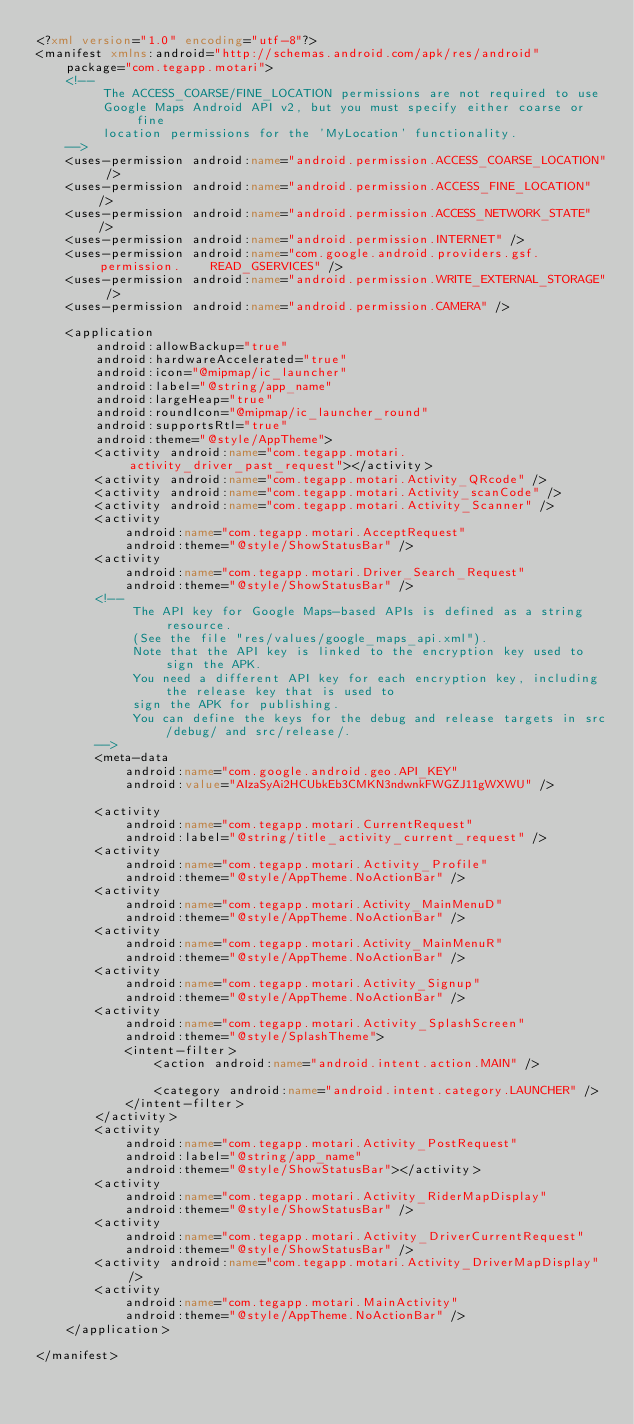<code> <loc_0><loc_0><loc_500><loc_500><_XML_><?xml version="1.0" encoding="utf-8"?>
<manifest xmlns:android="http://schemas.android.com/apk/res/android"
    package="com.tegapp.motari">
    <!--
         The ACCESS_COARSE/FINE_LOCATION permissions are not required to use
         Google Maps Android API v2, but you must specify either coarse or fine
         location permissions for the 'MyLocation' functionality.
    -->
    <uses-permission android:name="android.permission.ACCESS_COARSE_LOCATION" />
    <uses-permission android:name="android.permission.ACCESS_FINE_LOCATION" />
    <uses-permission android:name="android.permission.ACCESS_NETWORK_STATE" />
    <uses-permission android:name="android.permission.INTERNET" />
    <uses-permission android:name="com.google.android.providers.gsf.permission.    READ_GSERVICES" />
    <uses-permission android:name="android.permission.WRITE_EXTERNAL_STORAGE" />
    <uses-permission android:name="android.permission.CAMERA" />

    <application
        android:allowBackup="true"
        android:hardwareAccelerated="true"
        android:icon="@mipmap/ic_launcher"
        android:label="@string/app_name"
        android:largeHeap="true"
        android:roundIcon="@mipmap/ic_launcher_round"
        android:supportsRtl="true"
        android:theme="@style/AppTheme">
        <activity android:name="com.tegapp.motari.activity_driver_past_request"></activity>
        <activity android:name="com.tegapp.motari.Activity_QRcode" />
        <activity android:name="com.tegapp.motari.Activity_scanCode" />
        <activity android:name="com.tegapp.motari.Activity_Scanner" />
        <activity
            android:name="com.tegapp.motari.AcceptRequest"
            android:theme="@style/ShowStatusBar" />
        <activity
            android:name="com.tegapp.motari.Driver_Search_Request"
            android:theme="@style/ShowStatusBar" />
        <!--
             The API key for Google Maps-based APIs is defined as a string resource.
             (See the file "res/values/google_maps_api.xml").
             Note that the API key is linked to the encryption key used to sign the APK.
             You need a different API key for each encryption key, including the release key that is used to
             sign the APK for publishing.
             You can define the keys for the debug and release targets in src/debug/ and src/release/.
        -->
        <meta-data
            android:name="com.google.android.geo.API_KEY"
            android:value="AIzaSyAi2HCUbkEb3CMKN3ndwnkFWGZJ11gWXWU" />

        <activity
            android:name="com.tegapp.motari.CurrentRequest"
            android:label="@string/title_activity_current_request" />
        <activity
            android:name="com.tegapp.motari.Activity_Profile"
            android:theme="@style/AppTheme.NoActionBar" />
        <activity
            android:name="com.tegapp.motari.Activity_MainMenuD"
            android:theme="@style/AppTheme.NoActionBar" />
        <activity
            android:name="com.tegapp.motari.Activity_MainMenuR"
            android:theme="@style/AppTheme.NoActionBar" />
        <activity
            android:name="com.tegapp.motari.Activity_Signup"
            android:theme="@style/AppTheme.NoActionBar" />
        <activity
            android:name="com.tegapp.motari.Activity_SplashScreen"
            android:theme="@style/SplashTheme">
            <intent-filter>
                <action android:name="android.intent.action.MAIN" />

                <category android:name="android.intent.category.LAUNCHER" />
            </intent-filter>
        </activity>
        <activity
            android:name="com.tegapp.motari.Activity_PostRequest"
            android:label="@string/app_name"
            android:theme="@style/ShowStatusBar"></activity>
        <activity
            android:name="com.tegapp.motari.Activity_RiderMapDisplay"
            android:theme="@style/ShowStatusBar" />
        <activity
            android:name="com.tegapp.motari.Activity_DriverCurrentRequest"
            android:theme="@style/ShowStatusBar" />
        <activity android:name="com.tegapp.motari.Activity_DriverMapDisplay" />
        <activity
            android:name="com.tegapp.motari.MainActivity"
            android:theme="@style/AppTheme.NoActionBar" />
    </application>

</manifest></code> 